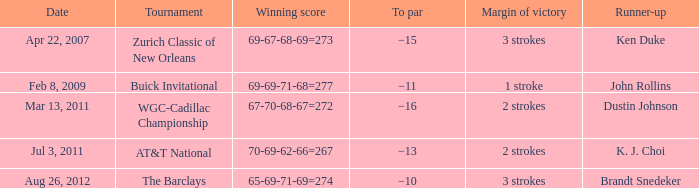What was the margin of victory when Brandt Snedeker was runner-up? 3 strokes. 